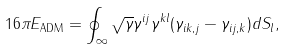Convert formula to latex. <formula><loc_0><loc_0><loc_500><loc_500>1 6 \pi E _ { \text {ADM} } = \oint _ { \infty } \sqrt { \gamma } \gamma ^ { i j } \gamma ^ { k l } ( \gamma _ { i k , j } - \gamma _ { i j , k } ) d S _ { l } ,</formula> 